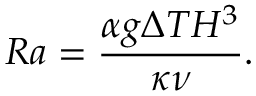<formula> <loc_0><loc_0><loc_500><loc_500>R a = \frac { \alpha g \Delta T H ^ { 3 } } { \kappa \nu } .</formula> 